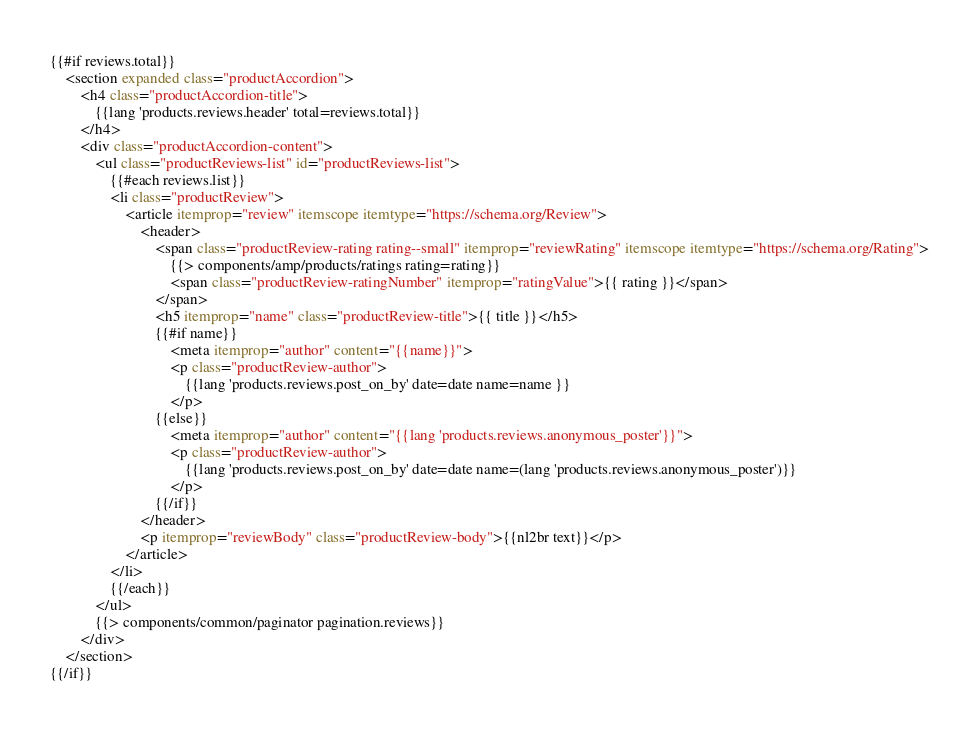<code> <loc_0><loc_0><loc_500><loc_500><_HTML_>{{#if reviews.total}}
    <section expanded class="productAccordion">
        <h4 class="productAccordion-title">
            {{lang 'products.reviews.header' total=reviews.total}}
        </h4>
        <div class="productAccordion-content">
            <ul class="productReviews-list" id="productReviews-list">
                {{#each reviews.list}}
                <li class="productReview">
                    <article itemprop="review" itemscope itemtype="https://schema.org/Review">
                        <header>
                            <span class="productReview-rating rating--small" itemprop="reviewRating" itemscope itemtype="https://schema.org/Rating">
                                {{> components/amp/products/ratings rating=rating}}
                                <span class="productReview-ratingNumber" itemprop="ratingValue">{{ rating }}</span>
                            </span>
                            <h5 itemprop="name" class="productReview-title">{{ title }}</h5>
                            {{#if name}}
                                <meta itemprop="author" content="{{name}}">
                                <p class="productReview-author">
                                    {{lang 'products.reviews.post_on_by' date=date name=name }}
                                </p>
                            {{else}}
                                <meta itemprop="author" content="{{lang 'products.reviews.anonymous_poster'}}">
                                <p class="productReview-author">
                                    {{lang 'products.reviews.post_on_by' date=date name=(lang 'products.reviews.anonymous_poster')}}
                                </p>
                            {{/if}}
                        </header>
                        <p itemprop="reviewBody" class="productReview-body">{{nl2br text}}</p>
                    </article>
                </li>
                {{/each}}
            </ul>
            {{> components/common/paginator pagination.reviews}}
        </div>
    </section>
{{/if}}
</code> 